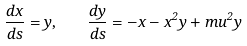<formula> <loc_0><loc_0><loc_500><loc_500>\frac { d x } { d s } = y , \quad \frac { d y } { d s } = - x - x ^ { 2 } y + m u ^ { 2 } y</formula> 